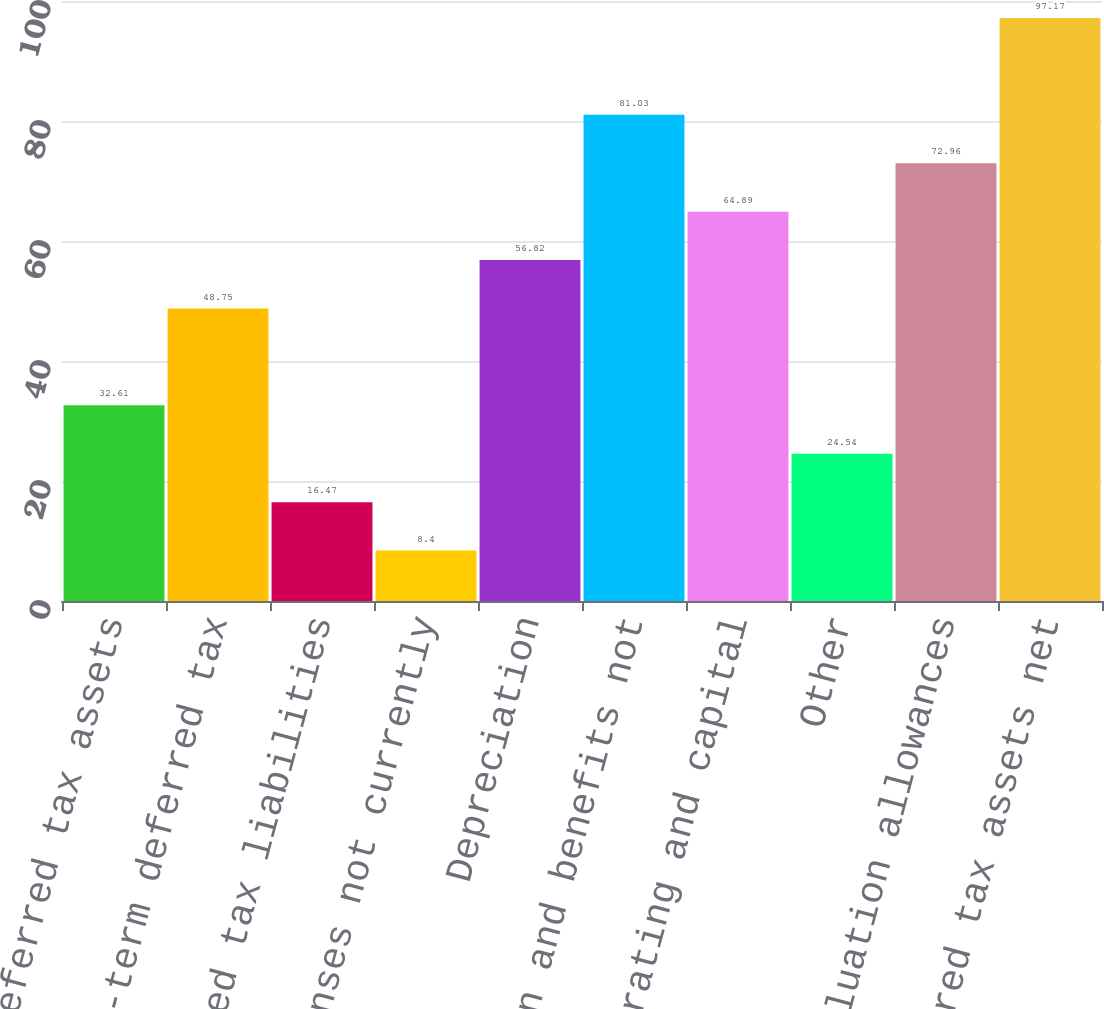Convert chart to OTSL. <chart><loc_0><loc_0><loc_500><loc_500><bar_chart><fcel>Current deferred tax assets<fcel>Long-term deferred tax<fcel>Net deferred tax liabilities<fcel>Accrued expenses not currently<fcel>Depreciation<fcel>Compensation and benefits not<fcel>Net operating and capital<fcel>Other<fcel>Less Valuation allowances<fcel>Deferred tax assets net<nl><fcel>32.61<fcel>48.75<fcel>16.47<fcel>8.4<fcel>56.82<fcel>81.03<fcel>64.89<fcel>24.54<fcel>72.96<fcel>97.17<nl></chart> 